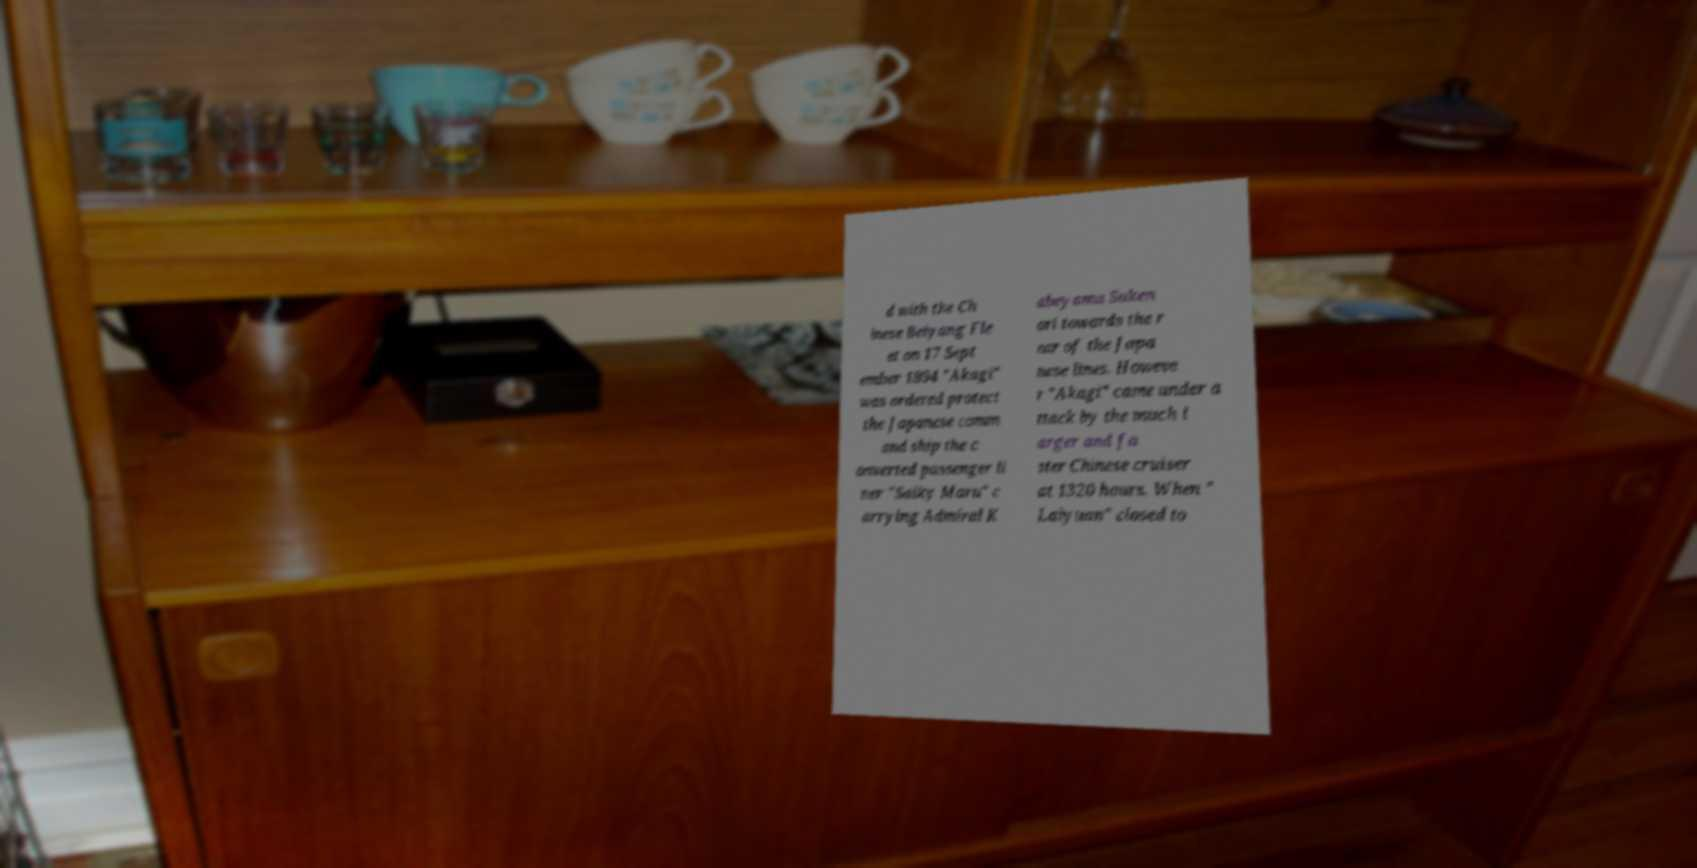I need the written content from this picture converted into text. Can you do that? d with the Ch inese Beiyang Fle et on 17 Sept ember 1894 "Akagi" was ordered protect the Japanese comm and ship the c onverted passenger li ner "Saiky Maru" c arrying Admiral K abeyama Suken ori towards the r ear of the Japa nese lines. Howeve r "Akagi" came under a ttack by the much l arger and fa ster Chinese cruiser at 1320 hours. When " Laiyuan" closed to 